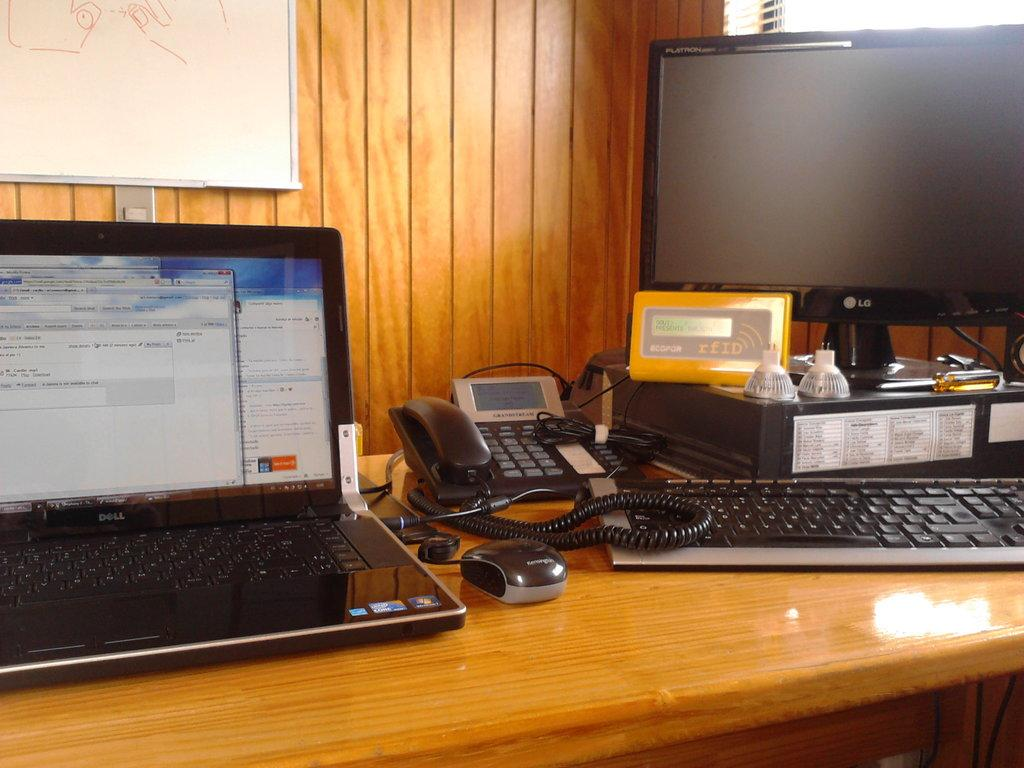What electronic device is visible in the image? There is a laptop in the image. What accessory is used with the laptop? There is a mouse in the image. What communication device is present in the image? There is a telephone in the image. What input device is visible in the image? There is a keyboard in the image. What display device is present in the image? There is a monitor in the image. Where are all these objects located? All these objects are on a table in the image. What additional item can be seen on the wall? There is a notice board in the image. What type of scent can be detected coming from the laptop in the image? There is no scent associated with the laptop in the image. How many pizzas are visible on the table in the image? There are no pizzas present in the image. 